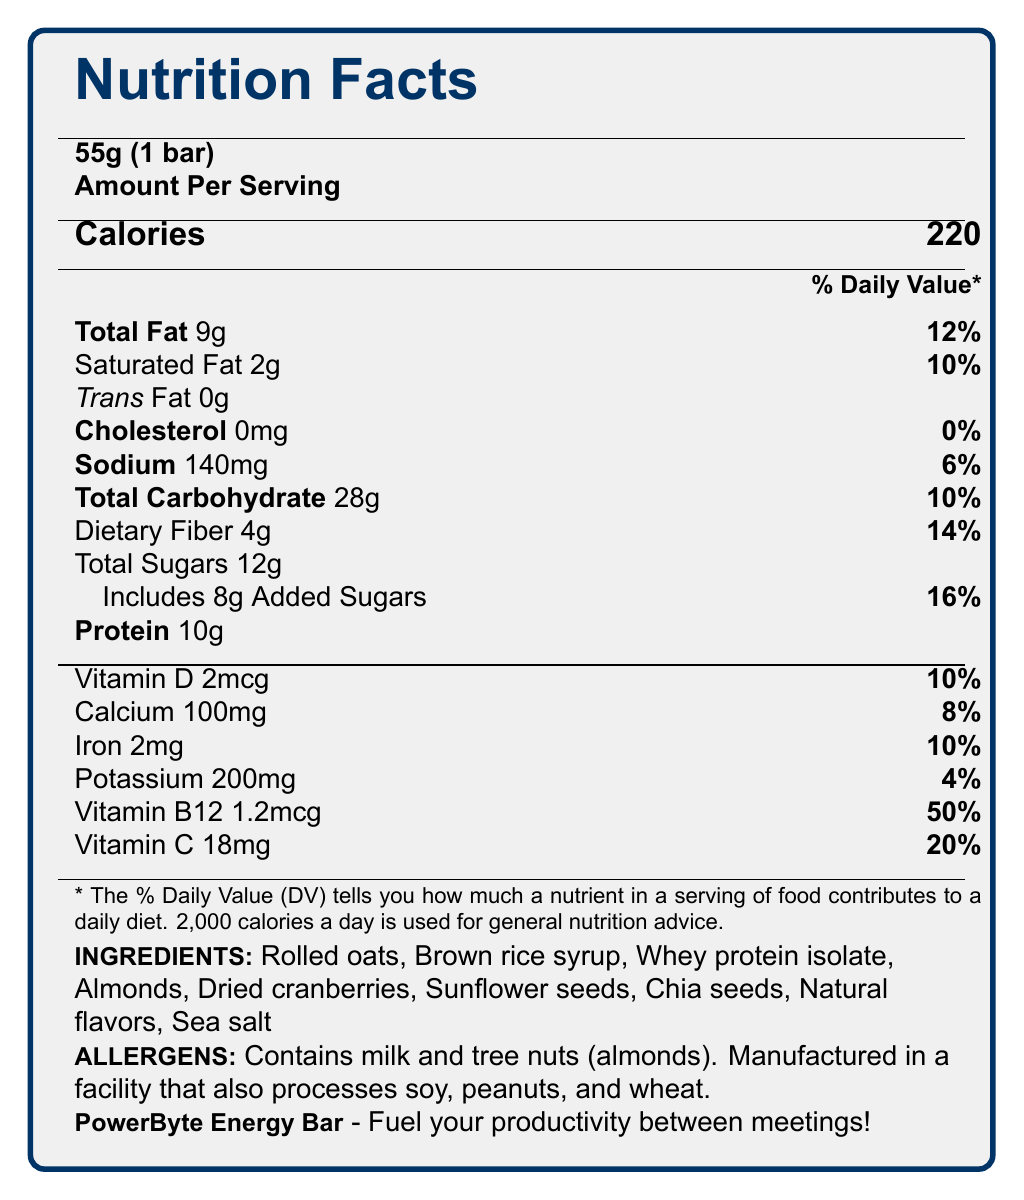what is the serving size? The serving size information is located at the top of the document under the Nutrition Facts title.
Answer: 55g (1 bar) how many grams of protein are in one serving of the PowerByte Energy Bar? The amount of protein is listed directly under the amount of sugars on the document.
Answer: 10g what percentage of the daily value for vitamin B12 does one bar provide? The information is listed in the vitamin and mineral section at the bottom of the nutrient list.
Answer: 50% does the PowerByte Energy Bar contain any trans fat? The document clearly states "Trans Fat 0g" in the fat content section.
Answer: No how much calcium (in mg) is in one bar of the PowerByte Energy Bar? The calcium content is found in the vitamins and minerals section of the document.
Answer: 100mg what are the allergens mentioned for this product? A. Dairy and peanuts B. Soy and peanuts C. Milk and tree nuts (almonds) D. Wheat and tree nuts The allergen information is listed in the ingredients section and indicates the presence of milk and tree nuts (almonds).
Answer: C how many calories are there per serving? A. 180 B. 200 C. 220 D. 250 The number of calories per serving is explicitly listed as 220 in the "Amount Per Serving" section.
Answer: C does this product have added sugars, and if so, how much? The document specifies "Includes 8g Added Sugars" under the total sugars content.
Answer: Yes, 8g is this product suitable for someone with a peanut allergy? The allergen section mentions that the product is manufactured in a facility that processes peanuts, thus it may not be safe for someone with a peanut allergy.
Answer: No what is the main idea of the document? The main sections covered are the serving size, calorie content, detailed breakdown of nutrients, ingredient list, allergen warnings, and product description.
Answer: The document provides the nutritional information, ingredients, allergens, and key nutritional benefits of the PowerByte Energy Bar, a snack designed for busy professionals. is the iron content in this snack bar higher than the calcium content? The document indicates the iron content as 2mg (10% DV) and calcium content as 100mg (8% DV).
Answer: No what nutrients contribute the highest percentage to the daily value per serving? Vitamin B12 contributes 50% of the daily value, and Vitamin C contributes 20%, which are the highest percentages listed in the vitamins and minerals section.
Answer: Vitamin B12 and Vitamin C how many servings per container are there? The document states there is 1 serving per container.
Answer: 1 is the product certified as organic? The document does not provide any information about an organic certification.
Answer: Not enough information how long can the PowerByte Energy Bar be stored according to the document? The storage life is listed under the shelf life information.
Answer: 12 months from the date of manufacture 